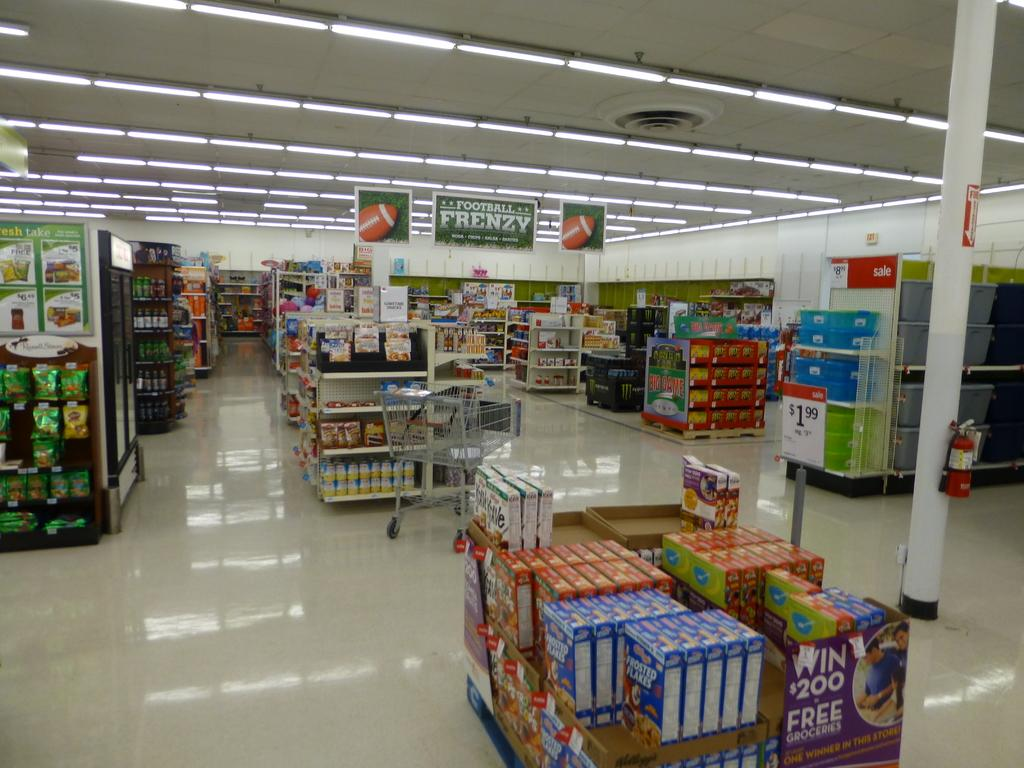<image>
Share a concise interpretation of the image provided. A football frenzy sign hangs in an aisle at a grocery store. 